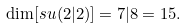<formula> <loc_0><loc_0><loc_500><loc_500>\dim [ s u ( 2 | 2 ) ] = 7 | 8 = 1 5 .</formula> 